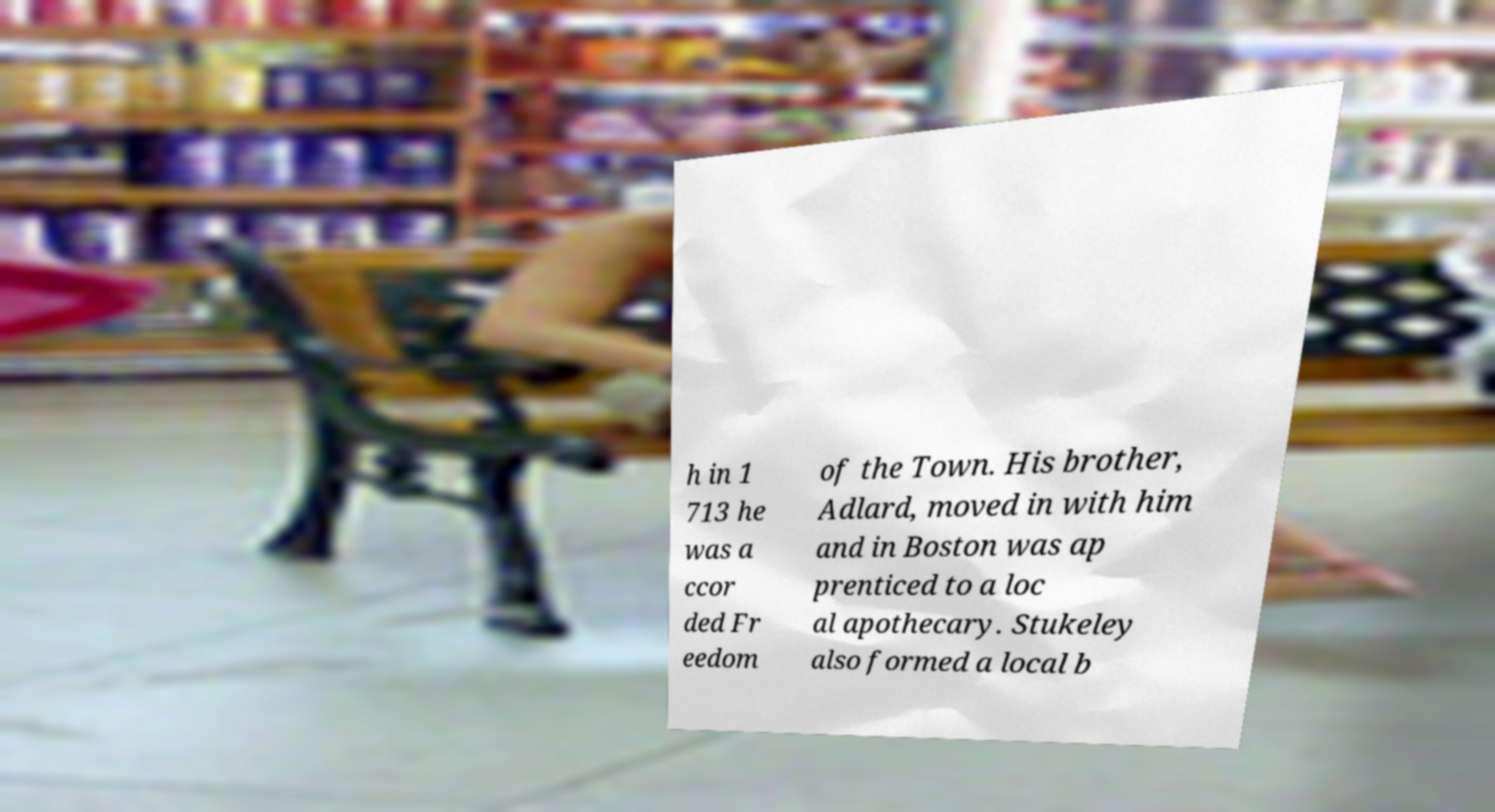Can you read and provide the text displayed in the image?This photo seems to have some interesting text. Can you extract and type it out for me? h in 1 713 he was a ccor ded Fr eedom of the Town. His brother, Adlard, moved in with him and in Boston was ap prenticed to a loc al apothecary. Stukeley also formed a local b 